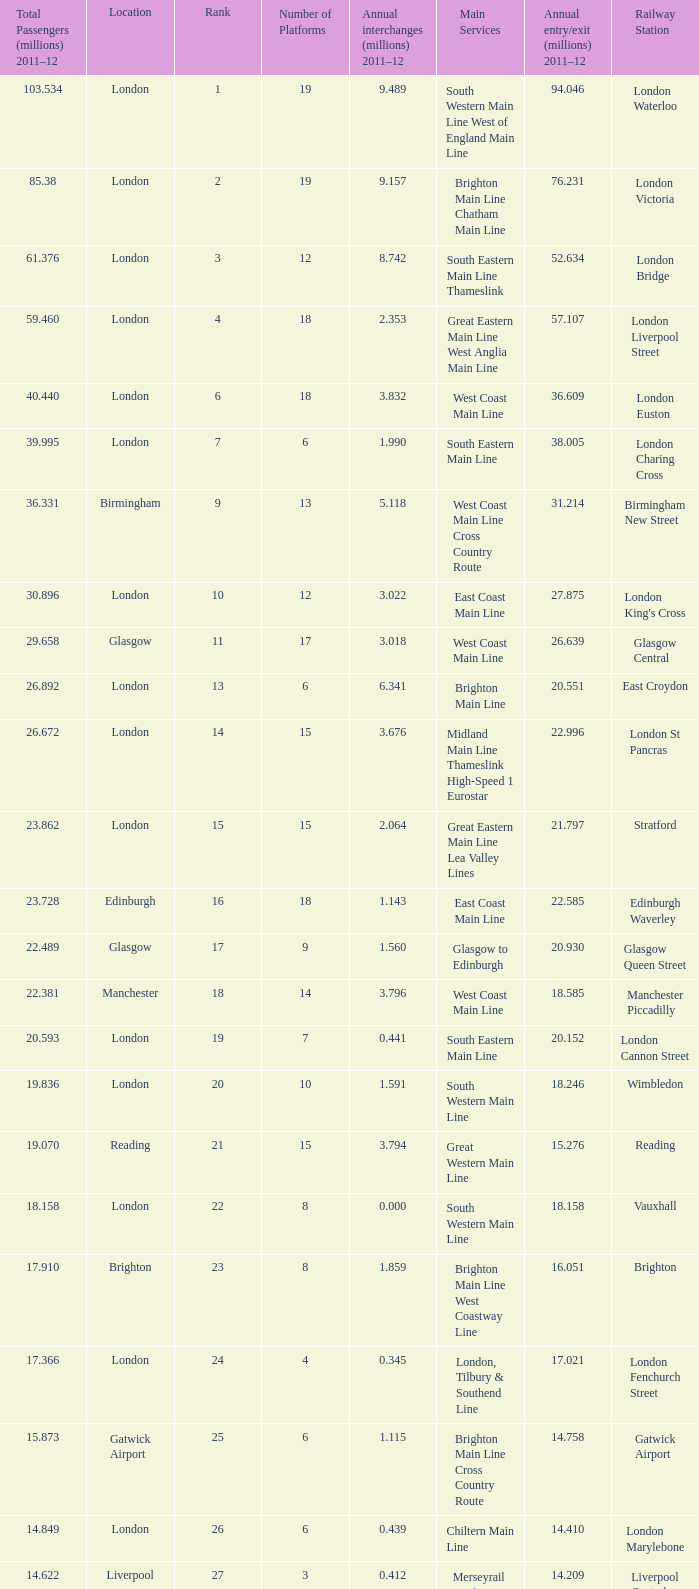How many annual interchanges in the millions occurred in 2011-12 when the number of annual entry/exits was 36.609 million?  3.832. 